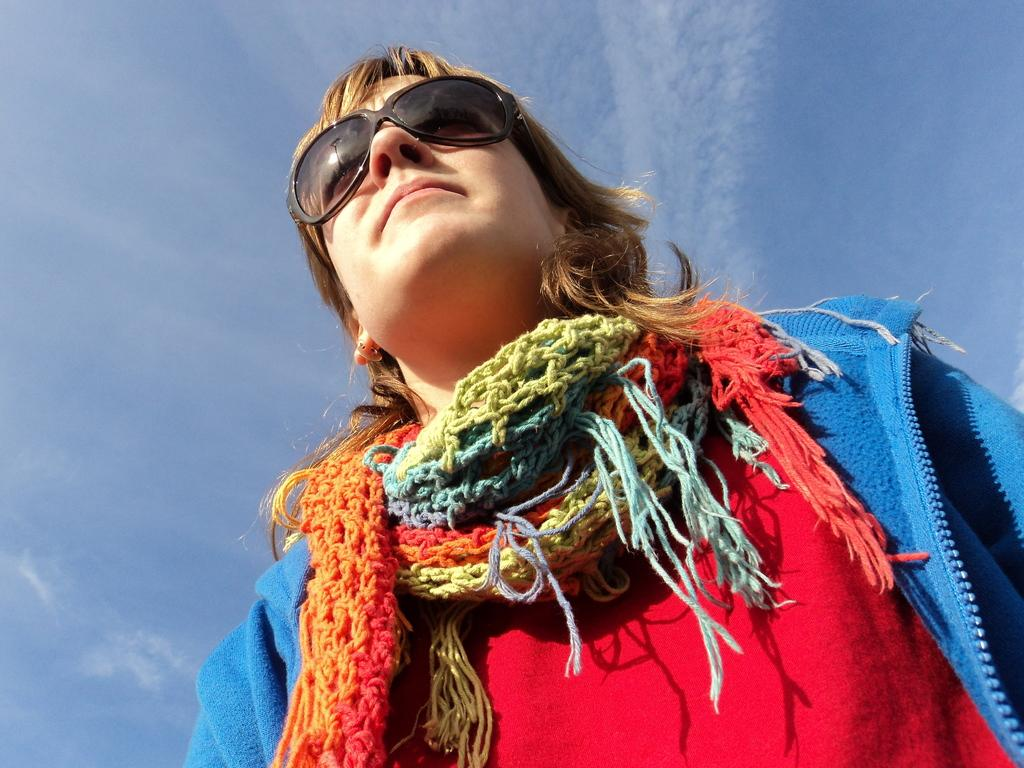What is the main subject of the image? There is a picture of a woman in the image. What is the woman wearing in the image? The woman is wearing goggles in the image. What can be seen in the background of the image? The background of the image features a blue sky. What type of shock can be seen affecting the woman in the image? There is no shock present in the image; the woman is simply wearing goggles. At what angle is the woman positioned in the image? The angle at which the woman is positioned cannot be determined from the image alone. 